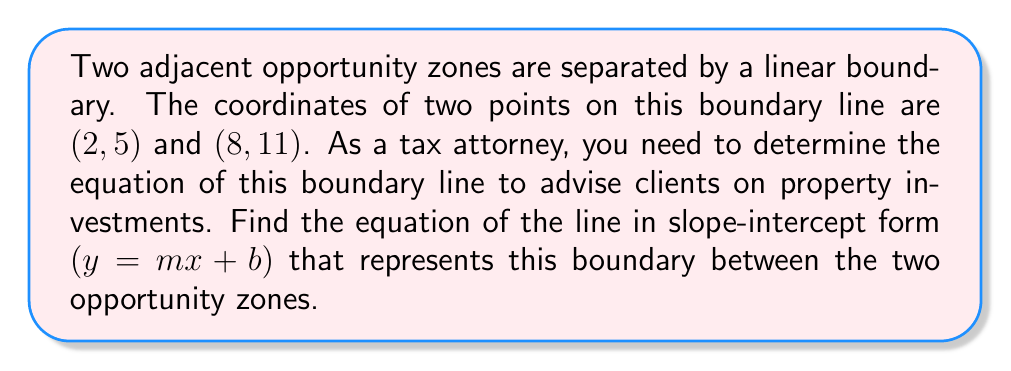Help me with this question. To find the equation of the line, we'll follow these steps:

1. Calculate the slope $(m)$ of the line using the two given points:
   $m = \frac{y_2 - y_1}{x_2 - x_1} = \frac{11 - 5}{8 - 2} = \frac{6}{6} = 1$

2. Use the point-slope form of a line: $y - y_1 = m(x - x_1)$
   Let's use the point (2, 5):
   $y - 5 = 1(x - 2)$

3. Expand the equation:
   $y - 5 = x - 2$

4. Solve for $y$ to get the slope-intercept form:
   $y = x - 2 + 5$
   $y = x + 3$

Therefore, the equation of the boundary line in slope-intercept form is $y = x + 3$.

[asy]
import geometry;

size(200);
draw((-1,-1)--(10,13), arrow=Arrow(TeXHead));
draw((-1,-1)--(10,-1), arrow=Arrow(TeXHead));

dot((2,5));
dot((8,11));

label("(2,5)", (2,5), SW);
label("(8,11)", (8,11), NE);

label("x", (10,-1), E);
label("y", (10,13), N);

draw((2,5)--(8,11), linewidth(2));
label("Opportunity Zone Boundary", (5,8), NW);
[/asy]
Answer: $y = x + 3$ 